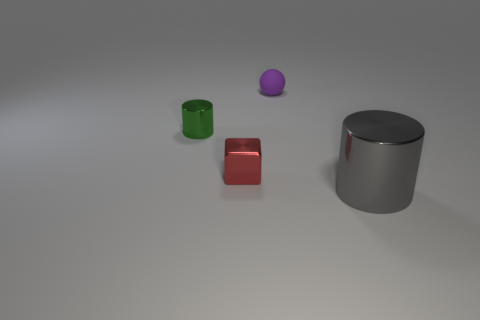Add 4 purple rubber balls. How many objects exist? 8 Subtract all spheres. How many objects are left? 3 Subtract all cyan blocks. How many gray cylinders are left? 1 Subtract all tiny cyan metallic cylinders. Subtract all cylinders. How many objects are left? 2 Add 3 big shiny things. How many big shiny things are left? 4 Add 4 blue shiny cylinders. How many blue shiny cylinders exist? 4 Subtract 0 green spheres. How many objects are left? 4 Subtract 1 blocks. How many blocks are left? 0 Subtract all yellow blocks. Subtract all green cylinders. How many blocks are left? 1 